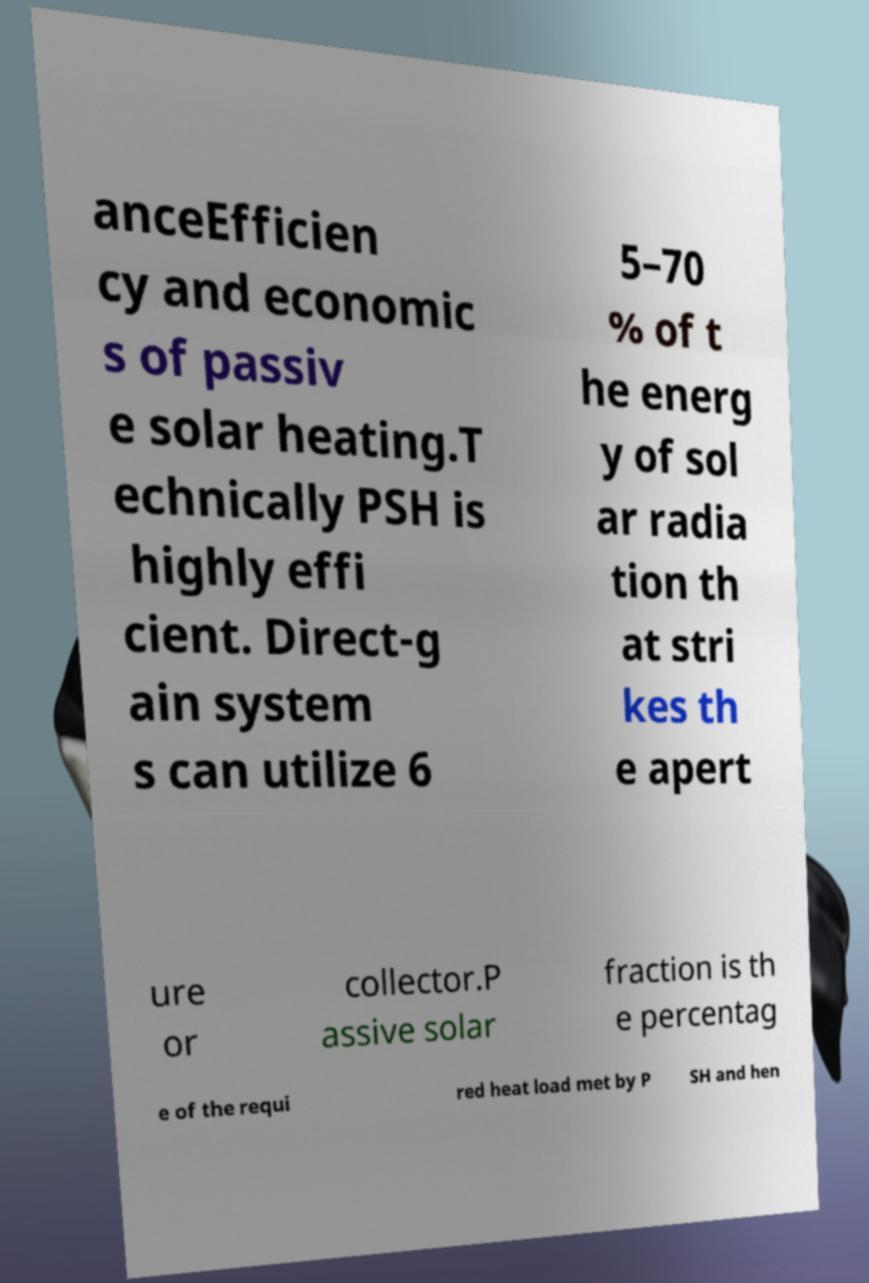Can you read and provide the text displayed in the image?This photo seems to have some interesting text. Can you extract and type it out for me? anceEfficien cy and economic s of passiv e solar heating.T echnically PSH is highly effi cient. Direct-g ain system s can utilize 6 5–70 % of t he energ y of sol ar radia tion th at stri kes th e apert ure or collector.P assive solar fraction is th e percentag e of the requi red heat load met by P SH and hen 